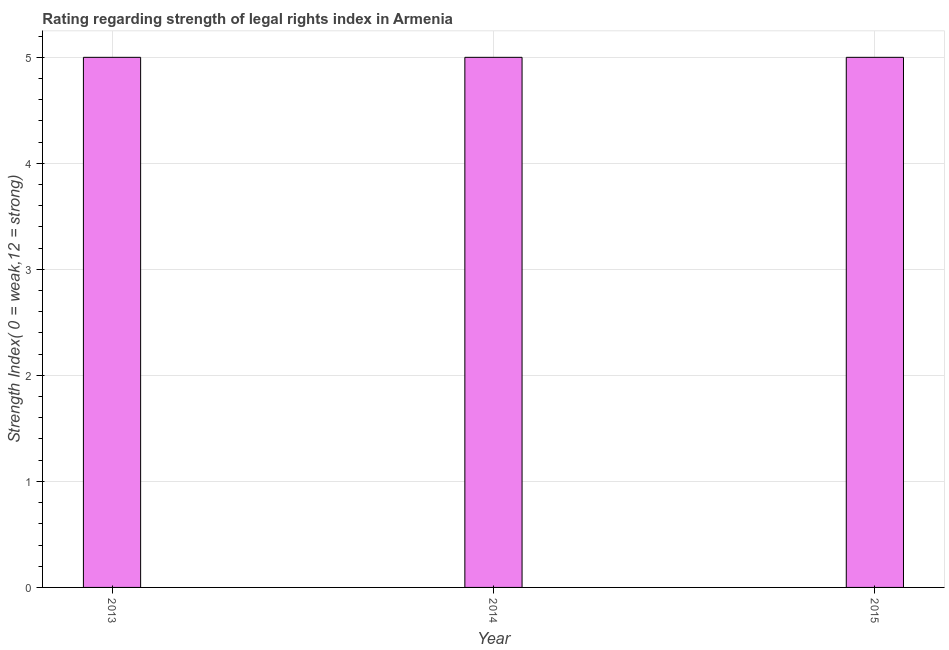What is the title of the graph?
Offer a terse response. Rating regarding strength of legal rights index in Armenia. What is the label or title of the Y-axis?
Your answer should be compact. Strength Index( 0 = weak,12 = strong). Across all years, what is the maximum strength of legal rights index?
Your answer should be very brief. 5. In which year was the strength of legal rights index minimum?
Offer a terse response. 2013. What is the median strength of legal rights index?
Ensure brevity in your answer.  5. Do a majority of the years between 2014 and 2013 (inclusive) have strength of legal rights index greater than 0.2 ?
Make the answer very short. No. What is the ratio of the strength of legal rights index in 2013 to that in 2015?
Offer a terse response. 1. Is the difference between the strength of legal rights index in 2013 and 2015 greater than the difference between any two years?
Your answer should be compact. Yes. What is the difference between the highest and the lowest strength of legal rights index?
Give a very brief answer. 0. In how many years, is the strength of legal rights index greater than the average strength of legal rights index taken over all years?
Your answer should be compact. 0. How many bars are there?
Give a very brief answer. 3. What is the difference between two consecutive major ticks on the Y-axis?
Keep it short and to the point. 1. What is the Strength Index( 0 = weak,12 = strong) of 2013?
Make the answer very short. 5. What is the Strength Index( 0 = weak,12 = strong) in 2014?
Keep it short and to the point. 5. What is the difference between the Strength Index( 0 = weak,12 = strong) in 2013 and 2014?
Make the answer very short. 0. What is the difference between the Strength Index( 0 = weak,12 = strong) in 2014 and 2015?
Give a very brief answer. 0. What is the ratio of the Strength Index( 0 = weak,12 = strong) in 2013 to that in 2014?
Provide a succinct answer. 1. What is the ratio of the Strength Index( 0 = weak,12 = strong) in 2013 to that in 2015?
Offer a very short reply. 1. What is the ratio of the Strength Index( 0 = weak,12 = strong) in 2014 to that in 2015?
Offer a very short reply. 1. 